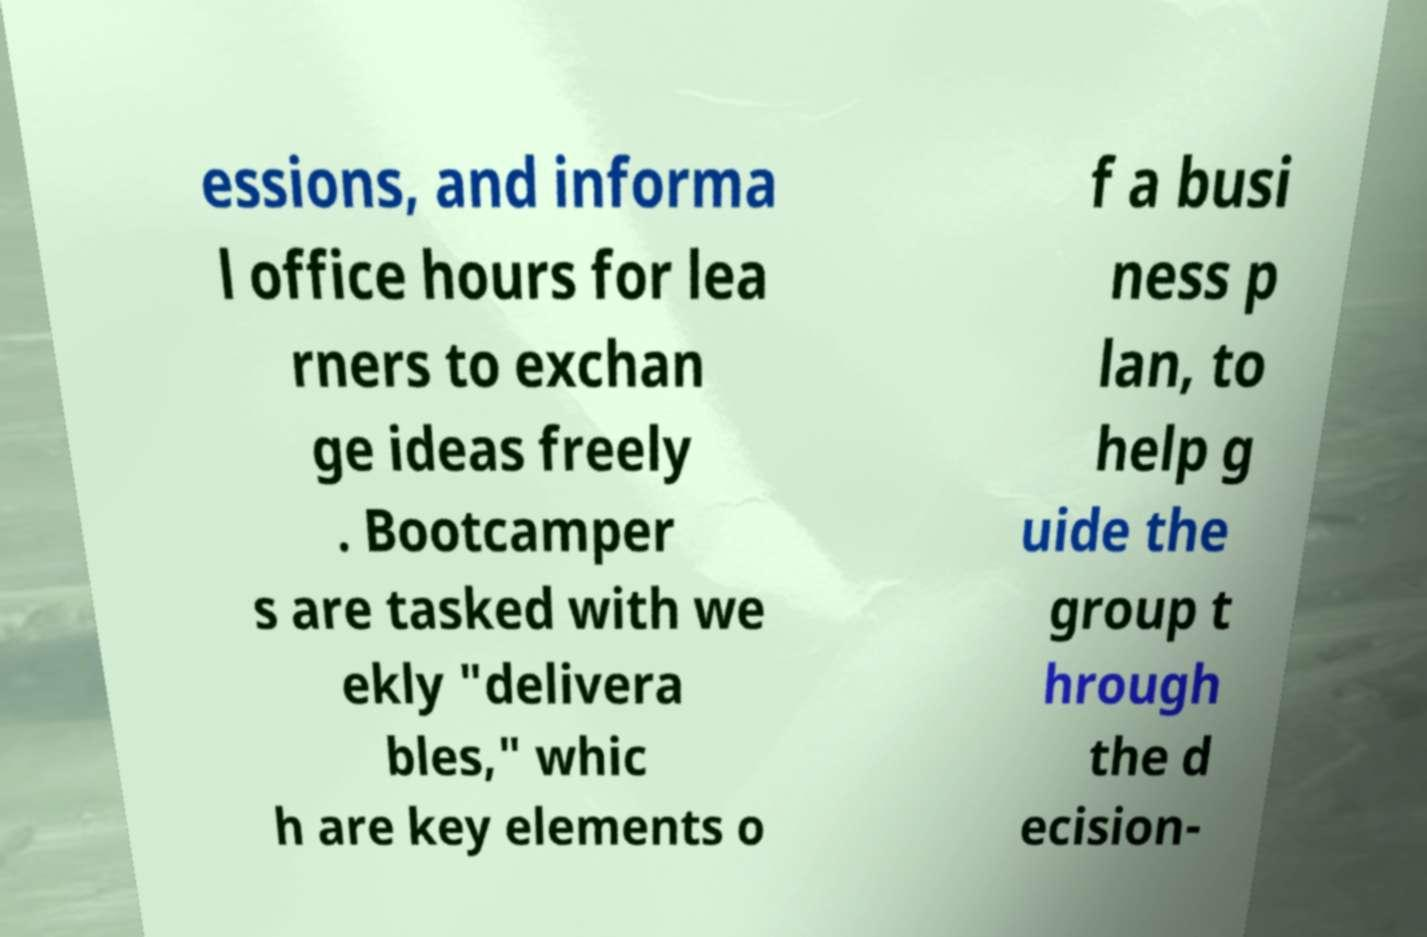What messages or text are displayed in this image? I need them in a readable, typed format. essions, and informa l office hours for lea rners to exchan ge ideas freely . Bootcamper s are tasked with we ekly "delivera bles," whic h are key elements o f a busi ness p lan, to help g uide the group t hrough the d ecision- 